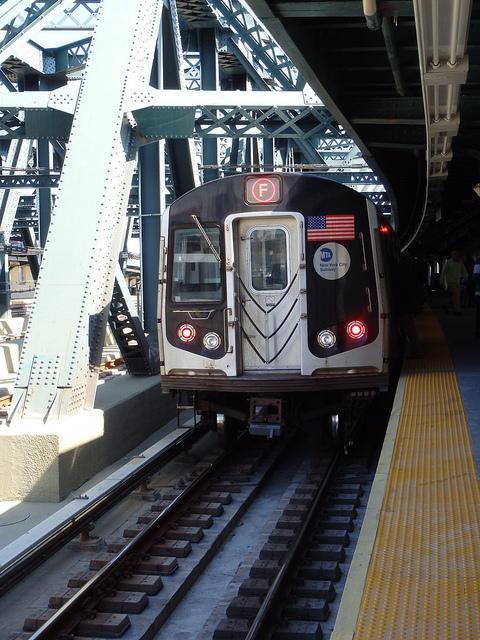How many of the boats in the front have yellow poles?
Give a very brief answer. 0. 